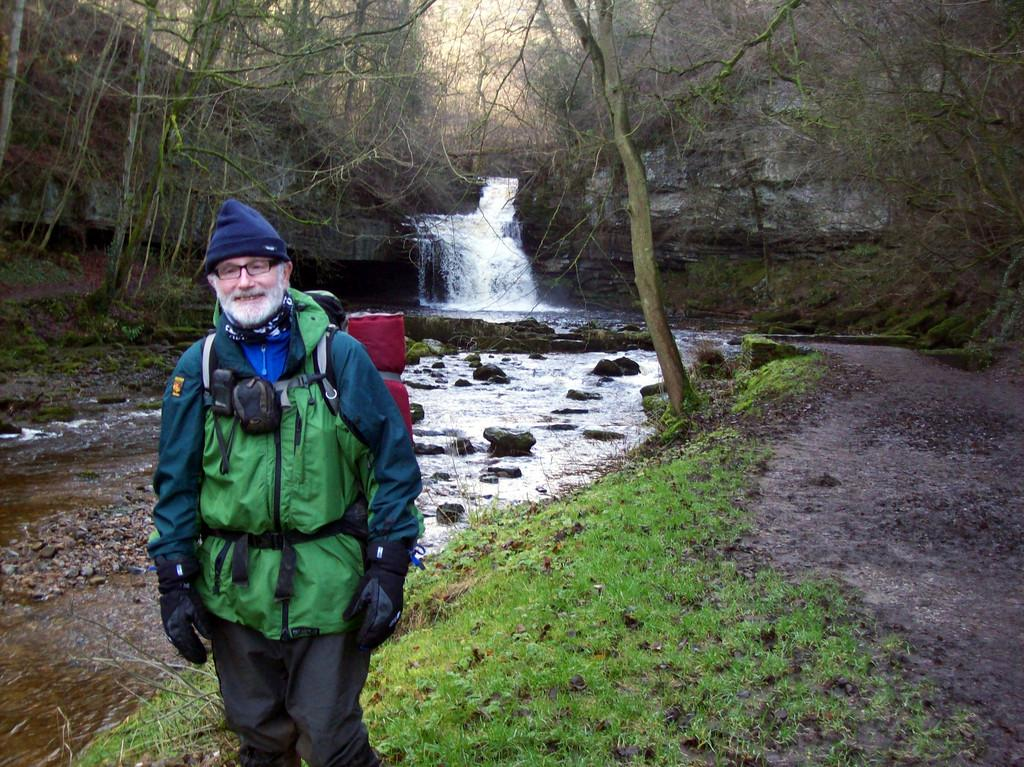Who is present in the image? There is a man in the image. What is the man wearing? The man is wearing a coat. Where is the man standing? The man is standing on a grass path. What can be seen in the background of the image? There is a waterfall, stones, trees, and a hill in the background of the image. What type of cabbage is being harvested by the man in the image? There is no cabbage present in the image, and the man is not shown harvesting anything. What is the man's reaction to the scarf in the image? There is no scarf present in the image, so it is not possible to determine the man's reaction to it. 